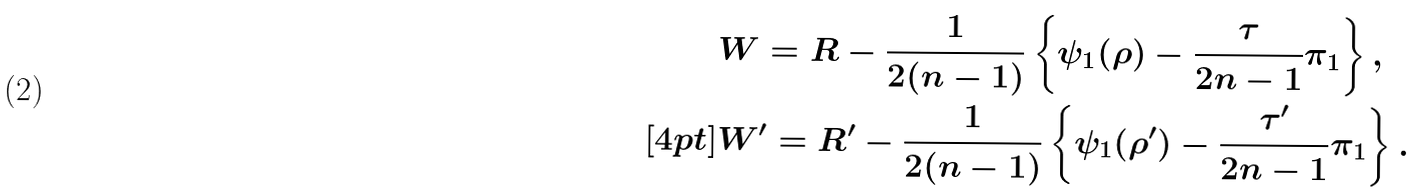Convert formula to latex. <formula><loc_0><loc_0><loc_500><loc_500>& W = R - \frac { 1 } { 2 ( n - 1 ) } \left \{ \psi _ { 1 } ( \rho ) - \frac { \tau } { 2 n - 1 } \pi _ { 1 } \right \} , \\ [ 4 p t ] & W ^ { \prime } = R ^ { \prime } - \frac { 1 } { 2 ( n - 1 ) } \left \{ \psi _ { 1 } ( \rho ^ { \prime } ) - \frac { \tau ^ { \prime } } { 2 n - 1 } \pi _ { 1 } \right \} .</formula> 